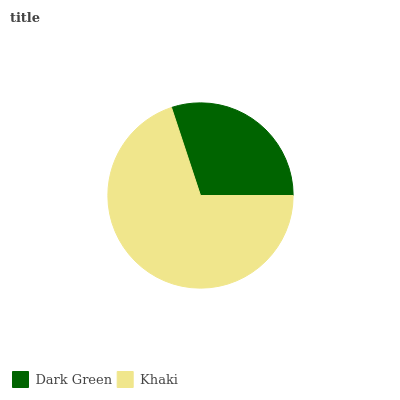Is Dark Green the minimum?
Answer yes or no. Yes. Is Khaki the maximum?
Answer yes or no. Yes. Is Khaki the minimum?
Answer yes or no. No. Is Khaki greater than Dark Green?
Answer yes or no. Yes. Is Dark Green less than Khaki?
Answer yes or no. Yes. Is Dark Green greater than Khaki?
Answer yes or no. No. Is Khaki less than Dark Green?
Answer yes or no. No. Is Khaki the high median?
Answer yes or no. Yes. Is Dark Green the low median?
Answer yes or no. Yes. Is Dark Green the high median?
Answer yes or no. No. Is Khaki the low median?
Answer yes or no. No. 